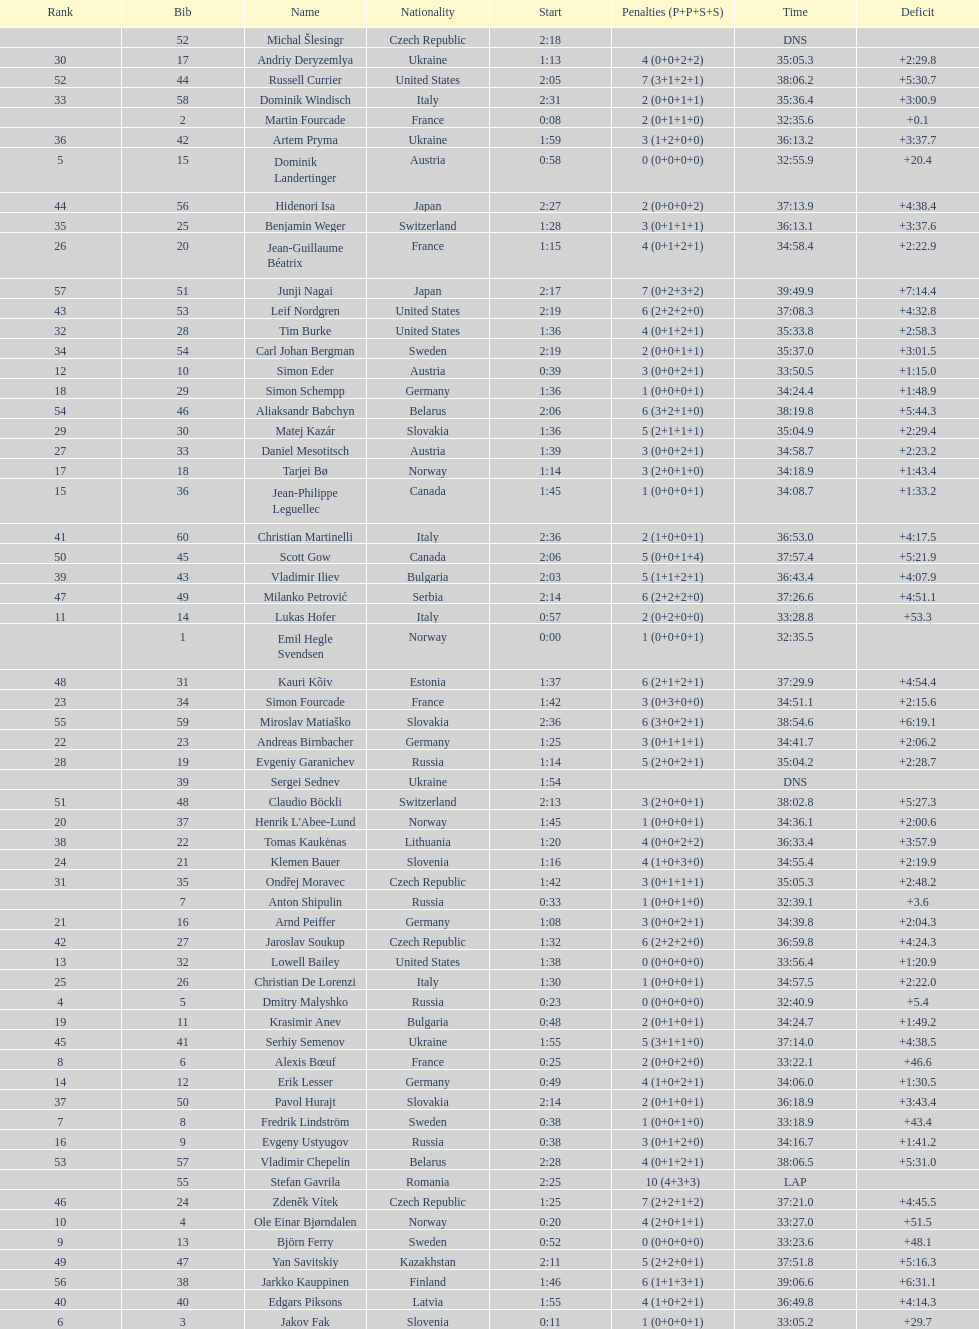Who is the top ranked runner of sweden? Fredrik Lindström. 